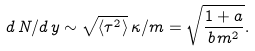Convert formula to latex. <formula><loc_0><loc_0><loc_500><loc_500>d \, N / d \, y \sim \sqrt { \langle \tau ^ { 2 } \rangle } \, \kappa / m = \sqrt { \frac { 1 + a } { b \, m ^ { 2 } } } .</formula> 